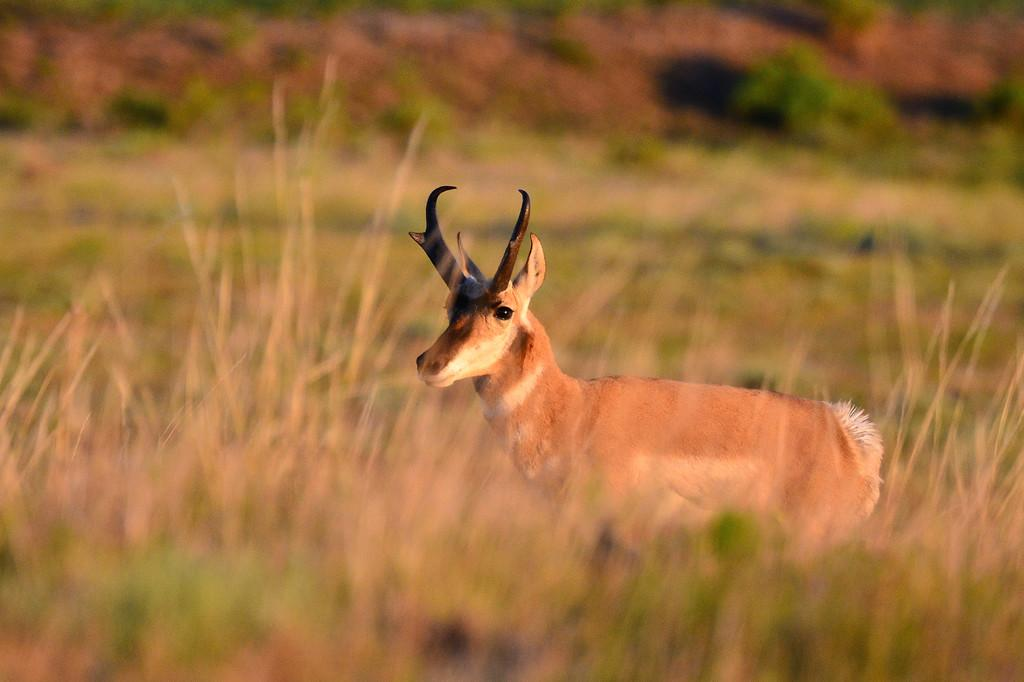What animal is in the middle of the image? There is a deer in the middle of the image. What type of vegetation is at the bottom of the image? There is grass at the bottom of the image. What can be seen in the background of the image? There are plants in the background of the image. Where is the toothbrush located in the image? There is no toothbrush present in the image. How many geese are visible in the image? There are no geese visible in the image. 